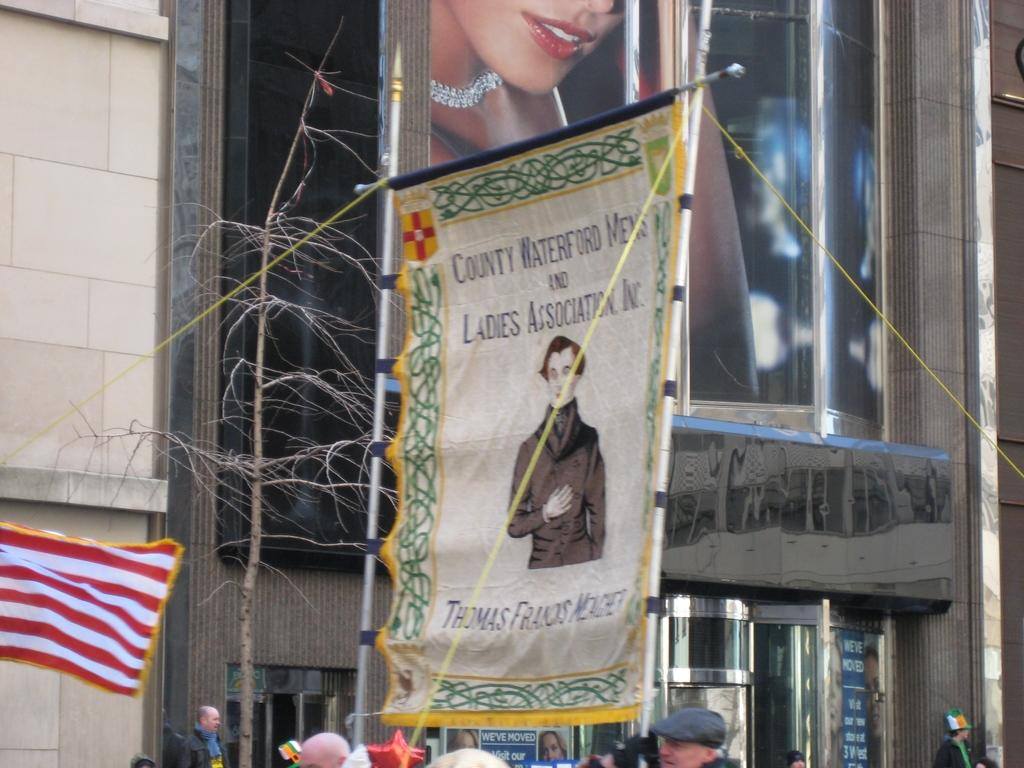What is the main subject of the poster in the image? The main subject of the poster in the image is a man. Where is the poster located in the image? The poster is in the middle of the image. Are there any people visible in the image? Yes, there are people at the bottom of the image. What type of engine can be seen powering the railway in the image? There is no engine or railway present in the image; it features a poster of a man and people at the bottom. What act are the people performing in the image? There is no specific act being performed by the people in the image; they are simply standing at the bottom. 